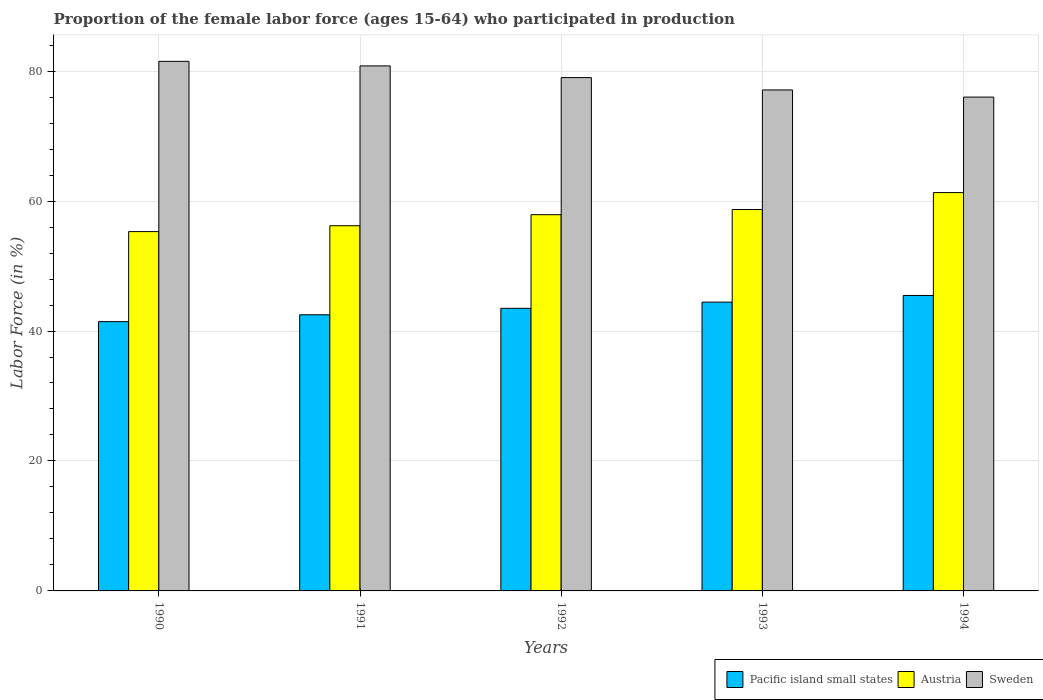How many different coloured bars are there?
Your answer should be compact. 3. Are the number of bars per tick equal to the number of legend labels?
Offer a terse response. Yes. How many bars are there on the 5th tick from the left?
Provide a short and direct response. 3. How many bars are there on the 4th tick from the right?
Offer a terse response. 3. In how many cases, is the number of bars for a given year not equal to the number of legend labels?
Your answer should be compact. 0. What is the proportion of the female labor force who participated in production in Pacific island small states in 1993?
Provide a short and direct response. 44.44. Across all years, what is the maximum proportion of the female labor force who participated in production in Pacific island small states?
Make the answer very short. 45.47. Across all years, what is the minimum proportion of the female labor force who participated in production in Pacific island small states?
Make the answer very short. 41.44. In which year was the proportion of the female labor force who participated in production in Austria minimum?
Provide a succinct answer. 1990. What is the total proportion of the female labor force who participated in production in Pacific island small states in the graph?
Provide a succinct answer. 217.34. What is the difference between the proportion of the female labor force who participated in production in Pacific island small states in 1991 and that in 1994?
Your response must be concise. -2.97. What is the difference between the proportion of the female labor force who participated in production in Austria in 1992 and the proportion of the female labor force who participated in production in Pacific island small states in 1990?
Offer a terse response. 16.46. What is the average proportion of the female labor force who participated in production in Austria per year?
Give a very brief answer. 57.88. In the year 1990, what is the difference between the proportion of the female labor force who participated in production in Sweden and proportion of the female labor force who participated in production in Pacific island small states?
Make the answer very short. 40.06. In how many years, is the proportion of the female labor force who participated in production in Sweden greater than 40 %?
Offer a terse response. 5. What is the ratio of the proportion of the female labor force who participated in production in Austria in 1990 to that in 1993?
Provide a short and direct response. 0.94. Is the difference between the proportion of the female labor force who participated in production in Sweden in 1990 and 1993 greater than the difference between the proportion of the female labor force who participated in production in Pacific island small states in 1990 and 1993?
Your answer should be very brief. Yes. What is the difference between the highest and the second highest proportion of the female labor force who participated in production in Pacific island small states?
Offer a very short reply. 1.02. What is the difference between the highest and the lowest proportion of the female labor force who participated in production in Sweden?
Make the answer very short. 5.5. What does the 1st bar from the left in 1990 represents?
Your answer should be compact. Pacific island small states. What does the 2nd bar from the right in 1991 represents?
Offer a terse response. Austria. Are all the bars in the graph horizontal?
Offer a very short reply. No. How many years are there in the graph?
Your response must be concise. 5. Are the values on the major ticks of Y-axis written in scientific E-notation?
Your answer should be compact. No. Where does the legend appear in the graph?
Provide a short and direct response. Bottom right. How many legend labels are there?
Provide a succinct answer. 3. What is the title of the graph?
Provide a succinct answer. Proportion of the female labor force (ages 15-64) who participated in production. Does "Belgium" appear as one of the legend labels in the graph?
Keep it short and to the point. No. What is the label or title of the Y-axis?
Your response must be concise. Labor Force (in %). What is the Labor Force (in %) of Pacific island small states in 1990?
Make the answer very short. 41.44. What is the Labor Force (in %) of Austria in 1990?
Provide a succinct answer. 55.3. What is the Labor Force (in %) of Sweden in 1990?
Provide a succinct answer. 81.5. What is the Labor Force (in %) of Pacific island small states in 1991?
Offer a terse response. 42.5. What is the Labor Force (in %) of Austria in 1991?
Keep it short and to the point. 56.2. What is the Labor Force (in %) in Sweden in 1991?
Provide a short and direct response. 80.8. What is the Labor Force (in %) in Pacific island small states in 1992?
Offer a terse response. 43.49. What is the Labor Force (in %) in Austria in 1992?
Keep it short and to the point. 57.9. What is the Labor Force (in %) of Sweden in 1992?
Provide a succinct answer. 79. What is the Labor Force (in %) in Pacific island small states in 1993?
Your answer should be very brief. 44.44. What is the Labor Force (in %) of Austria in 1993?
Your answer should be very brief. 58.7. What is the Labor Force (in %) of Sweden in 1993?
Make the answer very short. 77.1. What is the Labor Force (in %) in Pacific island small states in 1994?
Give a very brief answer. 45.47. What is the Labor Force (in %) of Austria in 1994?
Your answer should be compact. 61.3. What is the Labor Force (in %) of Sweden in 1994?
Keep it short and to the point. 76. Across all years, what is the maximum Labor Force (in %) in Pacific island small states?
Ensure brevity in your answer.  45.47. Across all years, what is the maximum Labor Force (in %) in Austria?
Your answer should be compact. 61.3. Across all years, what is the maximum Labor Force (in %) of Sweden?
Your answer should be compact. 81.5. Across all years, what is the minimum Labor Force (in %) of Pacific island small states?
Your answer should be compact. 41.44. Across all years, what is the minimum Labor Force (in %) in Austria?
Offer a terse response. 55.3. What is the total Labor Force (in %) in Pacific island small states in the graph?
Provide a short and direct response. 217.34. What is the total Labor Force (in %) of Austria in the graph?
Ensure brevity in your answer.  289.4. What is the total Labor Force (in %) of Sweden in the graph?
Your answer should be very brief. 394.4. What is the difference between the Labor Force (in %) in Pacific island small states in 1990 and that in 1991?
Provide a short and direct response. -1.05. What is the difference between the Labor Force (in %) in Pacific island small states in 1990 and that in 1992?
Your answer should be very brief. -2.05. What is the difference between the Labor Force (in %) in Austria in 1990 and that in 1992?
Make the answer very short. -2.6. What is the difference between the Labor Force (in %) in Pacific island small states in 1990 and that in 1993?
Offer a very short reply. -3. What is the difference between the Labor Force (in %) in Austria in 1990 and that in 1993?
Your answer should be very brief. -3.4. What is the difference between the Labor Force (in %) in Pacific island small states in 1990 and that in 1994?
Give a very brief answer. -4.03. What is the difference between the Labor Force (in %) of Pacific island small states in 1991 and that in 1992?
Ensure brevity in your answer.  -0.99. What is the difference between the Labor Force (in %) in Austria in 1991 and that in 1992?
Provide a short and direct response. -1.7. What is the difference between the Labor Force (in %) of Sweden in 1991 and that in 1992?
Make the answer very short. 1.8. What is the difference between the Labor Force (in %) of Pacific island small states in 1991 and that in 1993?
Ensure brevity in your answer.  -1.95. What is the difference between the Labor Force (in %) of Pacific island small states in 1991 and that in 1994?
Your answer should be compact. -2.97. What is the difference between the Labor Force (in %) in Pacific island small states in 1992 and that in 1993?
Your answer should be compact. -0.95. What is the difference between the Labor Force (in %) of Pacific island small states in 1992 and that in 1994?
Make the answer very short. -1.98. What is the difference between the Labor Force (in %) in Pacific island small states in 1993 and that in 1994?
Provide a succinct answer. -1.02. What is the difference between the Labor Force (in %) of Austria in 1993 and that in 1994?
Provide a succinct answer. -2.6. What is the difference between the Labor Force (in %) in Sweden in 1993 and that in 1994?
Your answer should be compact. 1.1. What is the difference between the Labor Force (in %) of Pacific island small states in 1990 and the Labor Force (in %) of Austria in 1991?
Keep it short and to the point. -14.76. What is the difference between the Labor Force (in %) of Pacific island small states in 1990 and the Labor Force (in %) of Sweden in 1991?
Give a very brief answer. -39.36. What is the difference between the Labor Force (in %) in Austria in 1990 and the Labor Force (in %) in Sweden in 1991?
Provide a succinct answer. -25.5. What is the difference between the Labor Force (in %) in Pacific island small states in 1990 and the Labor Force (in %) in Austria in 1992?
Offer a terse response. -16.46. What is the difference between the Labor Force (in %) in Pacific island small states in 1990 and the Labor Force (in %) in Sweden in 1992?
Give a very brief answer. -37.56. What is the difference between the Labor Force (in %) of Austria in 1990 and the Labor Force (in %) of Sweden in 1992?
Offer a terse response. -23.7. What is the difference between the Labor Force (in %) in Pacific island small states in 1990 and the Labor Force (in %) in Austria in 1993?
Your response must be concise. -17.26. What is the difference between the Labor Force (in %) of Pacific island small states in 1990 and the Labor Force (in %) of Sweden in 1993?
Keep it short and to the point. -35.66. What is the difference between the Labor Force (in %) of Austria in 1990 and the Labor Force (in %) of Sweden in 1993?
Your answer should be very brief. -21.8. What is the difference between the Labor Force (in %) of Pacific island small states in 1990 and the Labor Force (in %) of Austria in 1994?
Your answer should be very brief. -19.86. What is the difference between the Labor Force (in %) in Pacific island small states in 1990 and the Labor Force (in %) in Sweden in 1994?
Ensure brevity in your answer.  -34.56. What is the difference between the Labor Force (in %) of Austria in 1990 and the Labor Force (in %) of Sweden in 1994?
Give a very brief answer. -20.7. What is the difference between the Labor Force (in %) of Pacific island small states in 1991 and the Labor Force (in %) of Austria in 1992?
Offer a terse response. -15.4. What is the difference between the Labor Force (in %) in Pacific island small states in 1991 and the Labor Force (in %) in Sweden in 1992?
Ensure brevity in your answer.  -36.5. What is the difference between the Labor Force (in %) in Austria in 1991 and the Labor Force (in %) in Sweden in 1992?
Give a very brief answer. -22.8. What is the difference between the Labor Force (in %) in Pacific island small states in 1991 and the Labor Force (in %) in Austria in 1993?
Ensure brevity in your answer.  -16.2. What is the difference between the Labor Force (in %) in Pacific island small states in 1991 and the Labor Force (in %) in Sweden in 1993?
Your answer should be very brief. -34.6. What is the difference between the Labor Force (in %) of Austria in 1991 and the Labor Force (in %) of Sweden in 1993?
Your response must be concise. -20.9. What is the difference between the Labor Force (in %) in Pacific island small states in 1991 and the Labor Force (in %) in Austria in 1994?
Offer a terse response. -18.8. What is the difference between the Labor Force (in %) in Pacific island small states in 1991 and the Labor Force (in %) in Sweden in 1994?
Provide a short and direct response. -33.5. What is the difference between the Labor Force (in %) of Austria in 1991 and the Labor Force (in %) of Sweden in 1994?
Give a very brief answer. -19.8. What is the difference between the Labor Force (in %) in Pacific island small states in 1992 and the Labor Force (in %) in Austria in 1993?
Your response must be concise. -15.21. What is the difference between the Labor Force (in %) in Pacific island small states in 1992 and the Labor Force (in %) in Sweden in 1993?
Offer a very short reply. -33.61. What is the difference between the Labor Force (in %) in Austria in 1992 and the Labor Force (in %) in Sweden in 1993?
Give a very brief answer. -19.2. What is the difference between the Labor Force (in %) of Pacific island small states in 1992 and the Labor Force (in %) of Austria in 1994?
Your answer should be very brief. -17.81. What is the difference between the Labor Force (in %) in Pacific island small states in 1992 and the Labor Force (in %) in Sweden in 1994?
Your answer should be very brief. -32.51. What is the difference between the Labor Force (in %) of Austria in 1992 and the Labor Force (in %) of Sweden in 1994?
Your answer should be very brief. -18.1. What is the difference between the Labor Force (in %) in Pacific island small states in 1993 and the Labor Force (in %) in Austria in 1994?
Offer a very short reply. -16.86. What is the difference between the Labor Force (in %) in Pacific island small states in 1993 and the Labor Force (in %) in Sweden in 1994?
Keep it short and to the point. -31.56. What is the difference between the Labor Force (in %) in Austria in 1993 and the Labor Force (in %) in Sweden in 1994?
Offer a terse response. -17.3. What is the average Labor Force (in %) of Pacific island small states per year?
Offer a terse response. 43.47. What is the average Labor Force (in %) of Austria per year?
Your answer should be compact. 57.88. What is the average Labor Force (in %) of Sweden per year?
Ensure brevity in your answer.  78.88. In the year 1990, what is the difference between the Labor Force (in %) of Pacific island small states and Labor Force (in %) of Austria?
Your answer should be very brief. -13.86. In the year 1990, what is the difference between the Labor Force (in %) of Pacific island small states and Labor Force (in %) of Sweden?
Provide a succinct answer. -40.06. In the year 1990, what is the difference between the Labor Force (in %) in Austria and Labor Force (in %) in Sweden?
Provide a succinct answer. -26.2. In the year 1991, what is the difference between the Labor Force (in %) of Pacific island small states and Labor Force (in %) of Austria?
Offer a terse response. -13.7. In the year 1991, what is the difference between the Labor Force (in %) in Pacific island small states and Labor Force (in %) in Sweden?
Give a very brief answer. -38.3. In the year 1991, what is the difference between the Labor Force (in %) of Austria and Labor Force (in %) of Sweden?
Your answer should be compact. -24.6. In the year 1992, what is the difference between the Labor Force (in %) in Pacific island small states and Labor Force (in %) in Austria?
Give a very brief answer. -14.41. In the year 1992, what is the difference between the Labor Force (in %) of Pacific island small states and Labor Force (in %) of Sweden?
Keep it short and to the point. -35.51. In the year 1992, what is the difference between the Labor Force (in %) of Austria and Labor Force (in %) of Sweden?
Keep it short and to the point. -21.1. In the year 1993, what is the difference between the Labor Force (in %) in Pacific island small states and Labor Force (in %) in Austria?
Ensure brevity in your answer.  -14.26. In the year 1993, what is the difference between the Labor Force (in %) in Pacific island small states and Labor Force (in %) in Sweden?
Offer a very short reply. -32.66. In the year 1993, what is the difference between the Labor Force (in %) of Austria and Labor Force (in %) of Sweden?
Your answer should be very brief. -18.4. In the year 1994, what is the difference between the Labor Force (in %) of Pacific island small states and Labor Force (in %) of Austria?
Offer a terse response. -15.83. In the year 1994, what is the difference between the Labor Force (in %) in Pacific island small states and Labor Force (in %) in Sweden?
Your response must be concise. -30.53. In the year 1994, what is the difference between the Labor Force (in %) of Austria and Labor Force (in %) of Sweden?
Offer a terse response. -14.7. What is the ratio of the Labor Force (in %) in Pacific island small states in 1990 to that in 1991?
Give a very brief answer. 0.98. What is the ratio of the Labor Force (in %) in Austria in 1990 to that in 1991?
Ensure brevity in your answer.  0.98. What is the ratio of the Labor Force (in %) of Sweden in 1990 to that in 1991?
Provide a succinct answer. 1.01. What is the ratio of the Labor Force (in %) of Pacific island small states in 1990 to that in 1992?
Make the answer very short. 0.95. What is the ratio of the Labor Force (in %) of Austria in 1990 to that in 1992?
Provide a short and direct response. 0.96. What is the ratio of the Labor Force (in %) of Sweden in 1990 to that in 1992?
Provide a short and direct response. 1.03. What is the ratio of the Labor Force (in %) in Pacific island small states in 1990 to that in 1993?
Provide a short and direct response. 0.93. What is the ratio of the Labor Force (in %) in Austria in 1990 to that in 1993?
Provide a succinct answer. 0.94. What is the ratio of the Labor Force (in %) in Sweden in 1990 to that in 1993?
Your response must be concise. 1.06. What is the ratio of the Labor Force (in %) of Pacific island small states in 1990 to that in 1994?
Provide a short and direct response. 0.91. What is the ratio of the Labor Force (in %) in Austria in 1990 to that in 1994?
Keep it short and to the point. 0.9. What is the ratio of the Labor Force (in %) in Sweden in 1990 to that in 1994?
Your answer should be compact. 1.07. What is the ratio of the Labor Force (in %) of Pacific island small states in 1991 to that in 1992?
Ensure brevity in your answer.  0.98. What is the ratio of the Labor Force (in %) of Austria in 1991 to that in 1992?
Make the answer very short. 0.97. What is the ratio of the Labor Force (in %) of Sweden in 1991 to that in 1992?
Offer a terse response. 1.02. What is the ratio of the Labor Force (in %) of Pacific island small states in 1991 to that in 1993?
Provide a succinct answer. 0.96. What is the ratio of the Labor Force (in %) in Austria in 1991 to that in 1993?
Your answer should be very brief. 0.96. What is the ratio of the Labor Force (in %) in Sweden in 1991 to that in 1993?
Offer a terse response. 1.05. What is the ratio of the Labor Force (in %) of Pacific island small states in 1991 to that in 1994?
Your answer should be compact. 0.93. What is the ratio of the Labor Force (in %) of Austria in 1991 to that in 1994?
Give a very brief answer. 0.92. What is the ratio of the Labor Force (in %) of Sweden in 1991 to that in 1994?
Ensure brevity in your answer.  1.06. What is the ratio of the Labor Force (in %) in Pacific island small states in 1992 to that in 1993?
Provide a succinct answer. 0.98. What is the ratio of the Labor Force (in %) in Austria in 1992 to that in 1993?
Provide a short and direct response. 0.99. What is the ratio of the Labor Force (in %) in Sweden in 1992 to that in 1993?
Provide a succinct answer. 1.02. What is the ratio of the Labor Force (in %) in Pacific island small states in 1992 to that in 1994?
Keep it short and to the point. 0.96. What is the ratio of the Labor Force (in %) of Austria in 1992 to that in 1994?
Make the answer very short. 0.94. What is the ratio of the Labor Force (in %) of Sweden in 1992 to that in 1994?
Provide a short and direct response. 1.04. What is the ratio of the Labor Force (in %) of Pacific island small states in 1993 to that in 1994?
Your answer should be compact. 0.98. What is the ratio of the Labor Force (in %) in Austria in 1993 to that in 1994?
Keep it short and to the point. 0.96. What is the ratio of the Labor Force (in %) of Sweden in 1993 to that in 1994?
Your response must be concise. 1.01. What is the difference between the highest and the second highest Labor Force (in %) of Sweden?
Keep it short and to the point. 0.7. What is the difference between the highest and the lowest Labor Force (in %) of Pacific island small states?
Offer a terse response. 4.03. What is the difference between the highest and the lowest Labor Force (in %) of Sweden?
Provide a short and direct response. 5.5. 